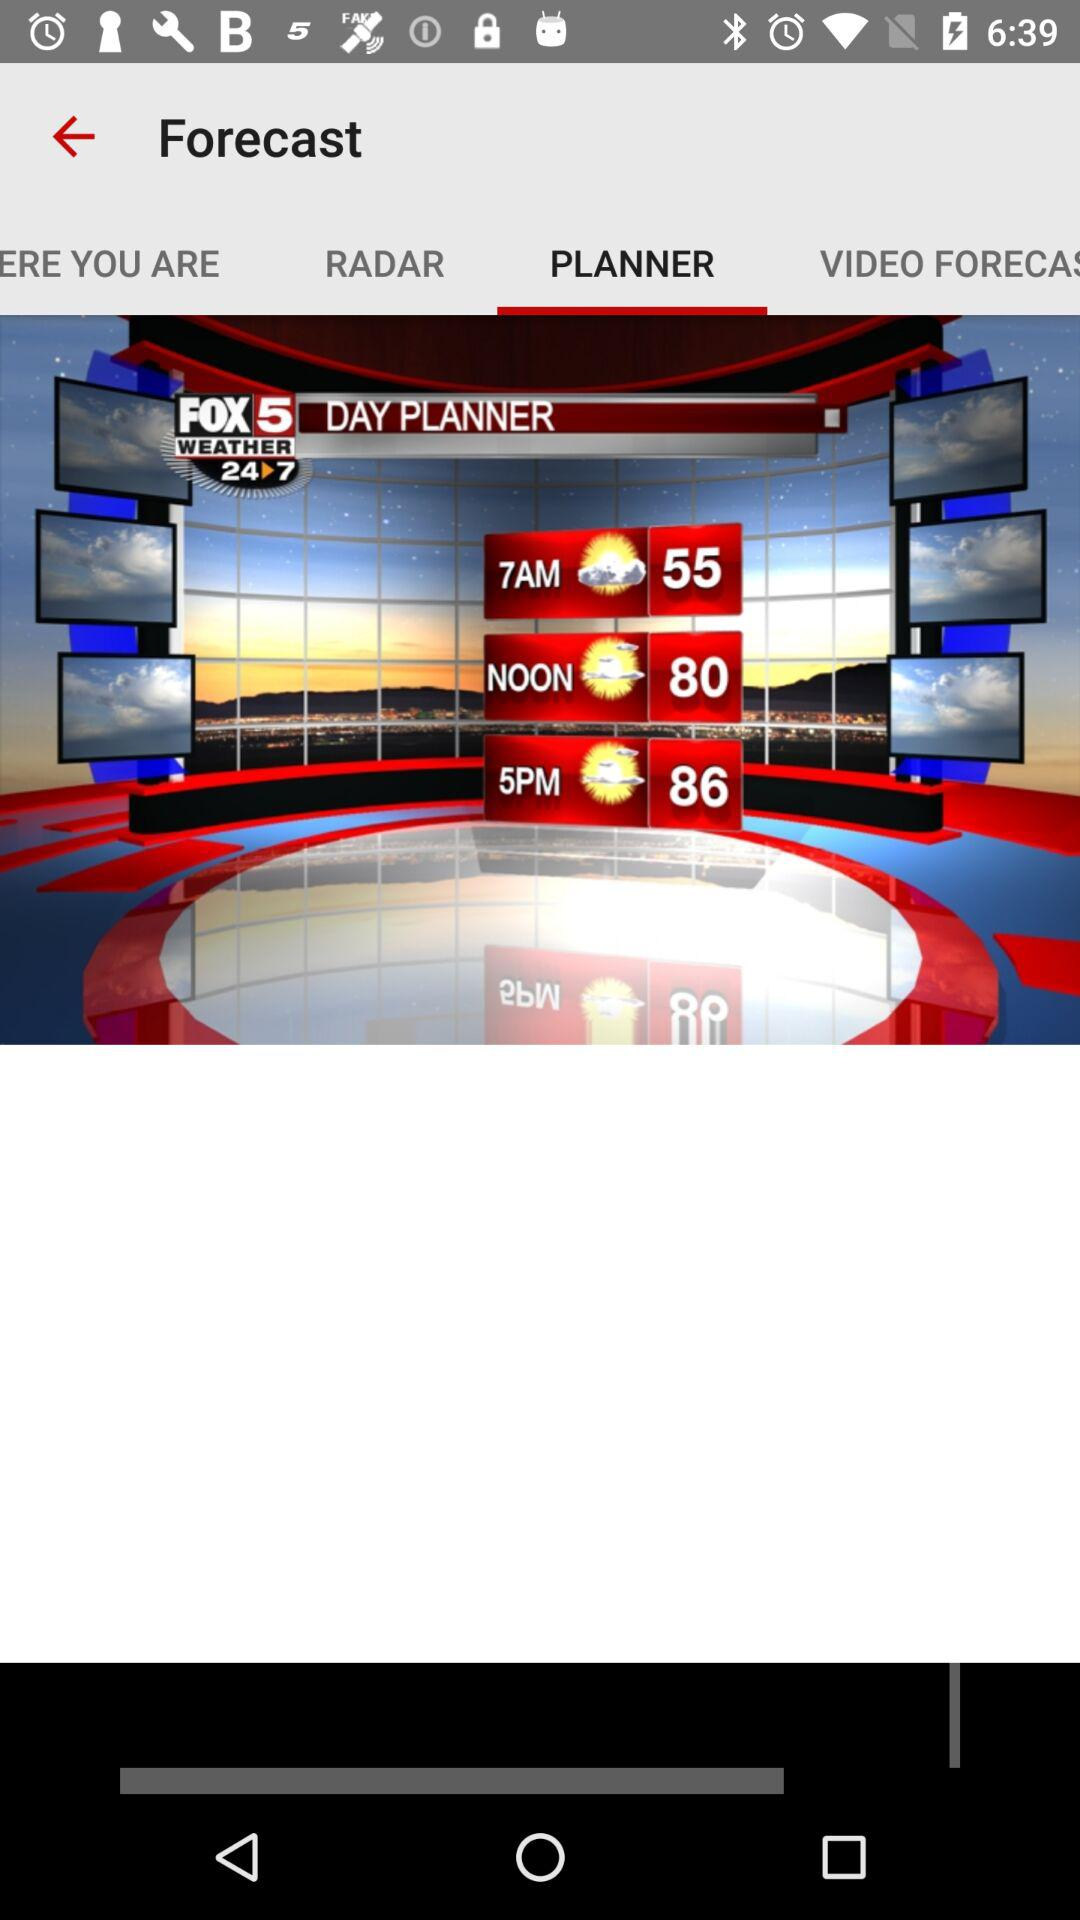What is the weather forecast for 7 a.m.? The weather forecast for 7 a.m. is partly cloudy. 